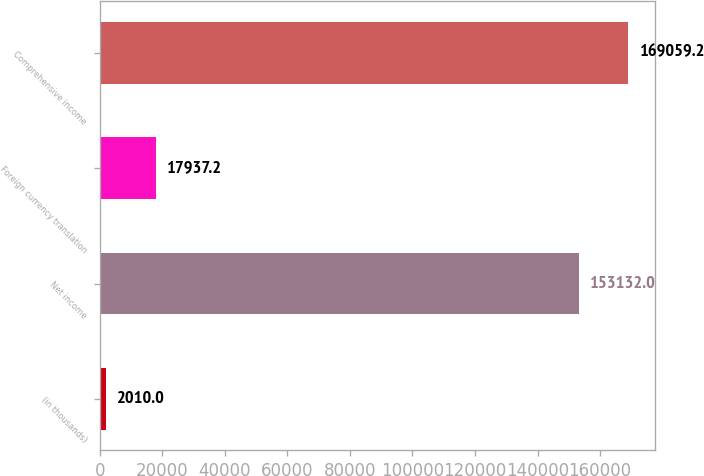Convert chart. <chart><loc_0><loc_0><loc_500><loc_500><bar_chart><fcel>(in thousands)<fcel>Net income<fcel>Foreign currency translation<fcel>Comprehensive income<nl><fcel>2010<fcel>153132<fcel>17937.2<fcel>169059<nl></chart> 